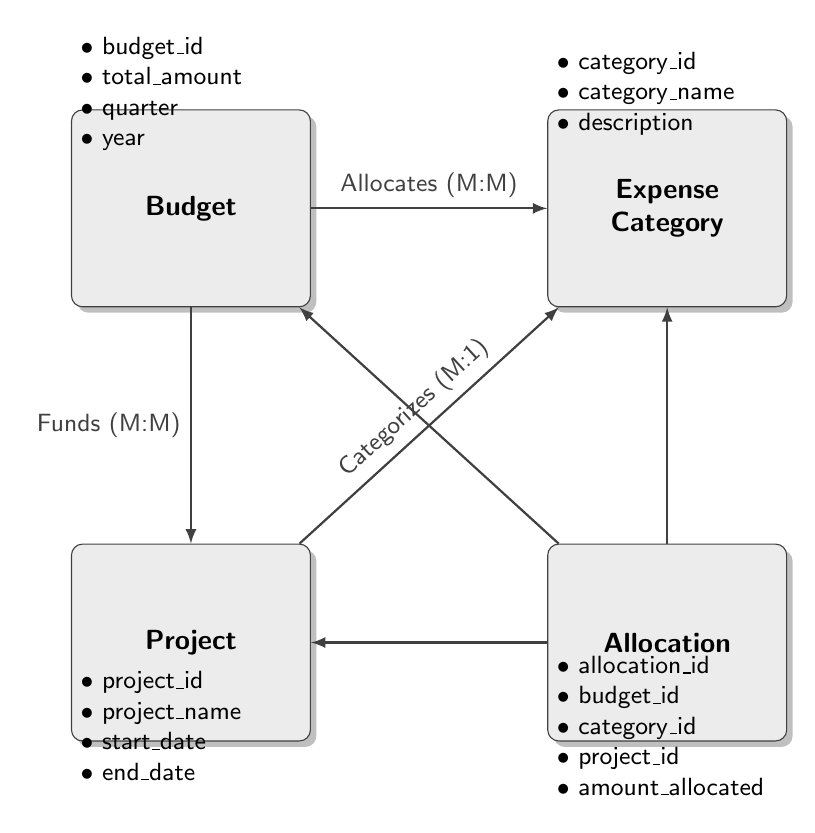What are the attributes of the Budget entity? The attributes of the Budget entity are listed directly in the diagram as bullet points under the Budget rectangle. They include budget_id, total_amount, quarter, and year.
Answer: budget_id, total_amount, quarter, year How many entities are present in the diagram? A count of the rectangles labeled as entities shows there are four entities: Budget, Expense Category, Project, and Allocation.
Answer: 4 What type of relationship exists between the Budget and Expense Category entities? The diagram shows an arrow labeled "Allocates (M:M)" connecting Budget and Expense Category, indicating a many-to-many relationship between them.
Answer: Many-to-Many Which entity categorizes the Expense Category? The diagram indicates that the Project entity categorizes the Expense Category, as shown by the arrow labeled "Categorizes (M:1)" connecting Project to Expense Category.
Answer: Project What information does the Allocation entity hold? The attributes listed for the Allocation entity provide the information it holds, which includes allocation_id, budget_id, category_id, project_id, and amount_allocated.
Answer: allocation_id, budget_id, category_id, project_id, amount_allocated Which entities are involved in the Funds relationship? The Funds relationship is indicated by the arrow labeled "Funds (M:M)" connecting Budget to Project, indicating that these two entities are involved in this relationship.
Answer: Budget, Project How is the amount allocated determined in the diagram? The amount allocated is specified within the Allocation entity, which connects Budget, Expense Category, and Project, indicating that the amount for each allocation is defined in this entity.
Answer: Allocation entity Which entity has the most relationships in the diagram? By evaluating the connections, it becomes clear that the Budget entity connects with both Expense Category and Project through many relationships, leading to three edges off the Budget entity in total.
Answer: Budget 